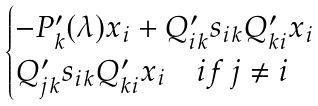Convert formula to latex. <formula><loc_0><loc_0><loc_500><loc_500>\begin{cases} - P ^ { \prime } _ { k } ( \lambda ) x _ { i } + Q ^ { \prime } _ { i k } s _ { i k } Q ^ { \prime } _ { k i } x _ { i } \\ Q ^ { \prime } _ { j k } s _ { i k } Q ^ { \prime } _ { k i } x _ { i } \quad i f \, j \not = i \\ \end{cases}</formula> 